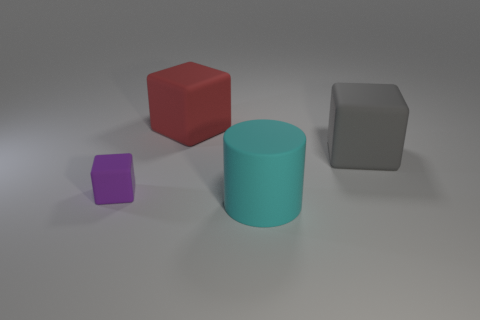There is a big block on the left side of the matte thing in front of the purple thing; are there any red cubes that are to the left of it?
Your answer should be compact. No. Are there any other things that are the same material as the large red cube?
Your response must be concise. Yes. What is the shape of the big cyan thing that is made of the same material as the large gray thing?
Offer a terse response. Cylinder. Are there fewer rubber blocks that are right of the purple matte cube than small purple matte things that are on the right side of the cyan object?
Your response must be concise. No. What number of tiny things are yellow shiny cubes or cylinders?
Your answer should be compact. 0. There is a matte thing right of the big matte cylinder; is its shape the same as the large matte thing on the left side of the big matte cylinder?
Keep it short and to the point. Yes. There is a rubber object behind the big rubber block to the right of the thing that is in front of the purple matte block; what size is it?
Provide a succinct answer. Large. There is a rubber cube that is right of the cyan matte thing; how big is it?
Offer a terse response. Large. What is the thing that is in front of the purple matte cube made of?
Your response must be concise. Rubber. What number of purple objects are either big rubber things or things?
Your answer should be very brief. 1. 